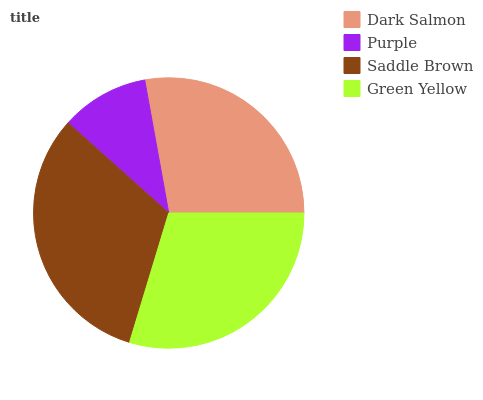Is Purple the minimum?
Answer yes or no. Yes. Is Saddle Brown the maximum?
Answer yes or no. Yes. Is Saddle Brown the minimum?
Answer yes or no. No. Is Purple the maximum?
Answer yes or no. No. Is Saddle Brown greater than Purple?
Answer yes or no. Yes. Is Purple less than Saddle Brown?
Answer yes or no. Yes. Is Purple greater than Saddle Brown?
Answer yes or no. No. Is Saddle Brown less than Purple?
Answer yes or no. No. Is Green Yellow the high median?
Answer yes or no. Yes. Is Dark Salmon the low median?
Answer yes or no. Yes. Is Saddle Brown the high median?
Answer yes or no. No. Is Purple the low median?
Answer yes or no. No. 